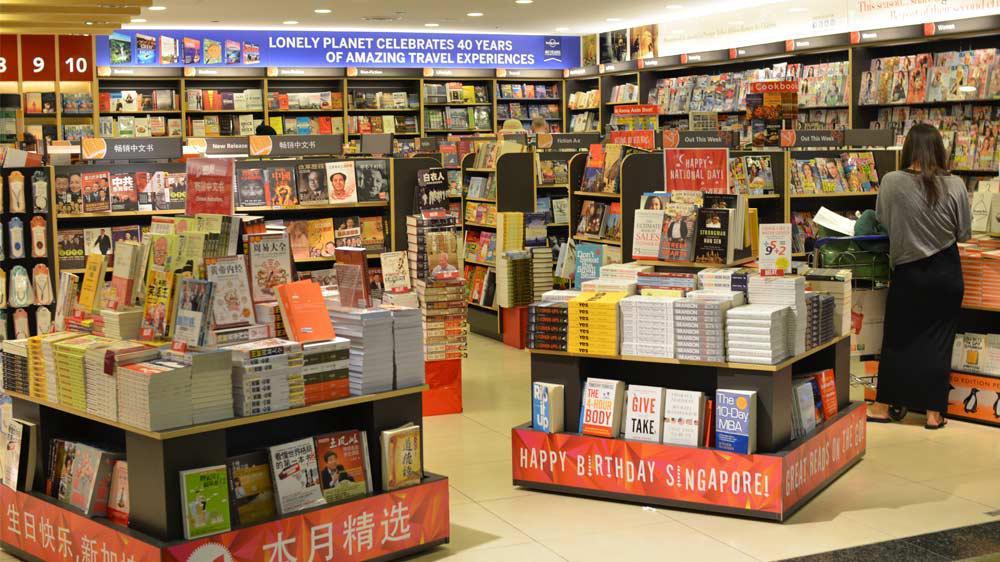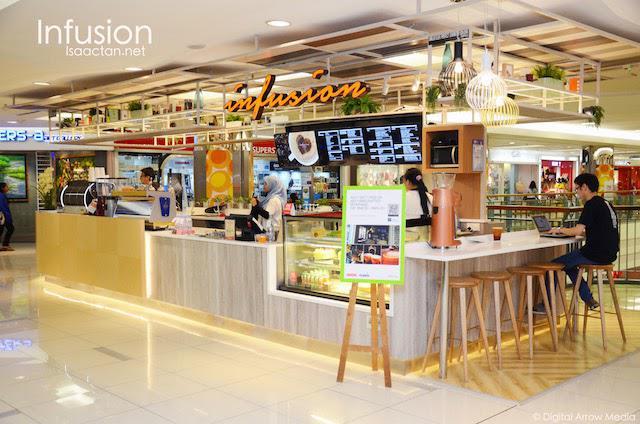The first image is the image on the left, the second image is the image on the right. Given the left and right images, does the statement "An image shows a shop interior which includes displays of apparel." hold true? Answer yes or no. No. 